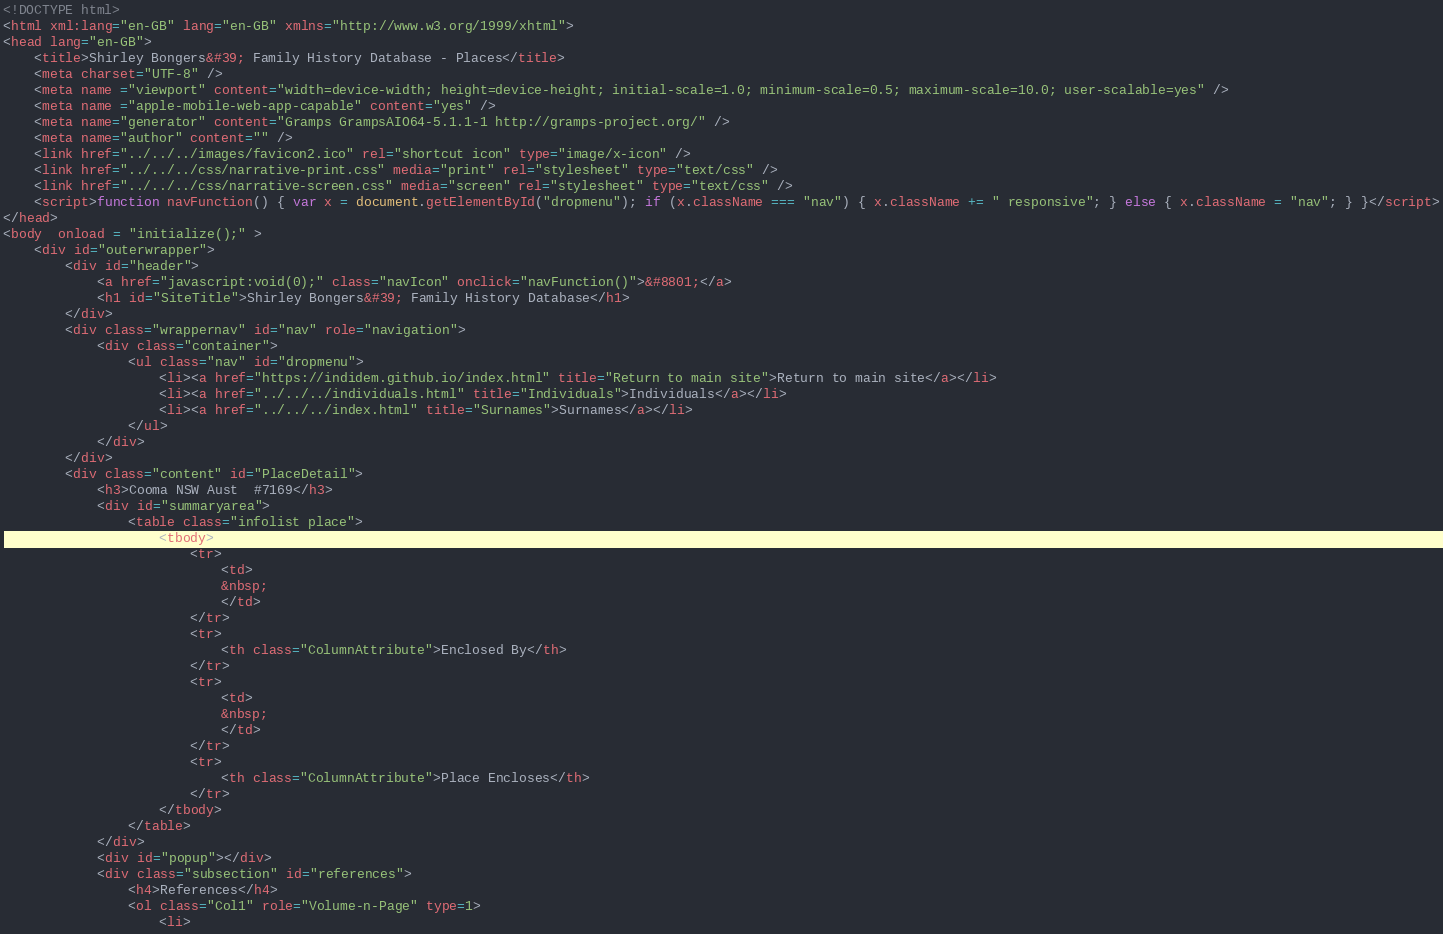<code> <loc_0><loc_0><loc_500><loc_500><_HTML_><!DOCTYPE html>
<html xml:lang="en-GB" lang="en-GB" xmlns="http://www.w3.org/1999/xhtml">
<head lang="en-GB">
	<title>Shirley Bongers&#39; Family History Database - Places</title>
	<meta charset="UTF-8" />
	<meta name ="viewport" content="width=device-width; height=device-height; initial-scale=1.0; minimum-scale=0.5; maximum-scale=10.0; user-scalable=yes" />
	<meta name ="apple-mobile-web-app-capable" content="yes" />
	<meta name="generator" content="Gramps GrampsAIO64-5.1.1-1 http://gramps-project.org/" />
	<meta name="author" content="" />
	<link href="../../../images/favicon2.ico" rel="shortcut icon" type="image/x-icon" />
	<link href="../../../css/narrative-print.css" media="print" rel="stylesheet" type="text/css" />
	<link href="../../../css/narrative-screen.css" media="screen" rel="stylesheet" type="text/css" />
	<script>function navFunction() { var x = document.getElementById("dropmenu"); if (x.className === "nav") { x.className += " responsive"; } else { x.className = "nav"; } }</script>
</head>
<body  onload = "initialize();" >
	<div id="outerwrapper">
		<div id="header">
			<a href="javascript:void(0);" class="navIcon" onclick="navFunction()">&#8801;</a>
			<h1 id="SiteTitle">Shirley Bongers&#39; Family History Database</h1>
		</div>
		<div class="wrappernav" id="nav" role="navigation">
			<div class="container">
				<ul class="nav" id="dropmenu">
					<li><a href="https://indidem.github.io/index.html" title="Return to main site">Return to main site</a></li>
					<li><a href="../../../individuals.html" title="Individuals">Individuals</a></li>
					<li><a href="../../../index.html" title="Surnames">Surnames</a></li>
				</ul>
			</div>
		</div>
		<div class="content" id="PlaceDetail">
			<h3>Cooma NSW Aust  #7169</h3>
			<div id="summaryarea">
				<table class="infolist place">
					<tbody>
						<tr>
							<td>
							&nbsp;
							</td>
						</tr>
						<tr>
							<th class="ColumnAttribute">Enclosed By</th>
						</tr>
						<tr>
							<td>
							&nbsp;
							</td>
						</tr>
						<tr>
							<th class="ColumnAttribute">Place Encloses</th>
						</tr>
					</tbody>
				</table>
			</div>
			<div id="popup"></div>
			<div class="subsection" id="references">
				<h4>References</h4>
				<ol class="Col1" role="Volume-n-Page" type=1>
					<li></code> 